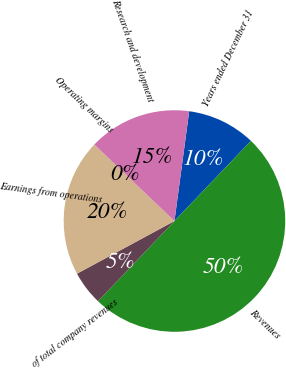Convert chart to OTSL. <chart><loc_0><loc_0><loc_500><loc_500><pie_chart><fcel>Years ended December 31<fcel>Revenues<fcel>of total company revenues<fcel>Earnings from operations<fcel>Operating margins<fcel>Research and development<nl><fcel>10.0%<fcel>49.99%<fcel>5.0%<fcel>20.0%<fcel>0.01%<fcel>15.0%<nl></chart> 